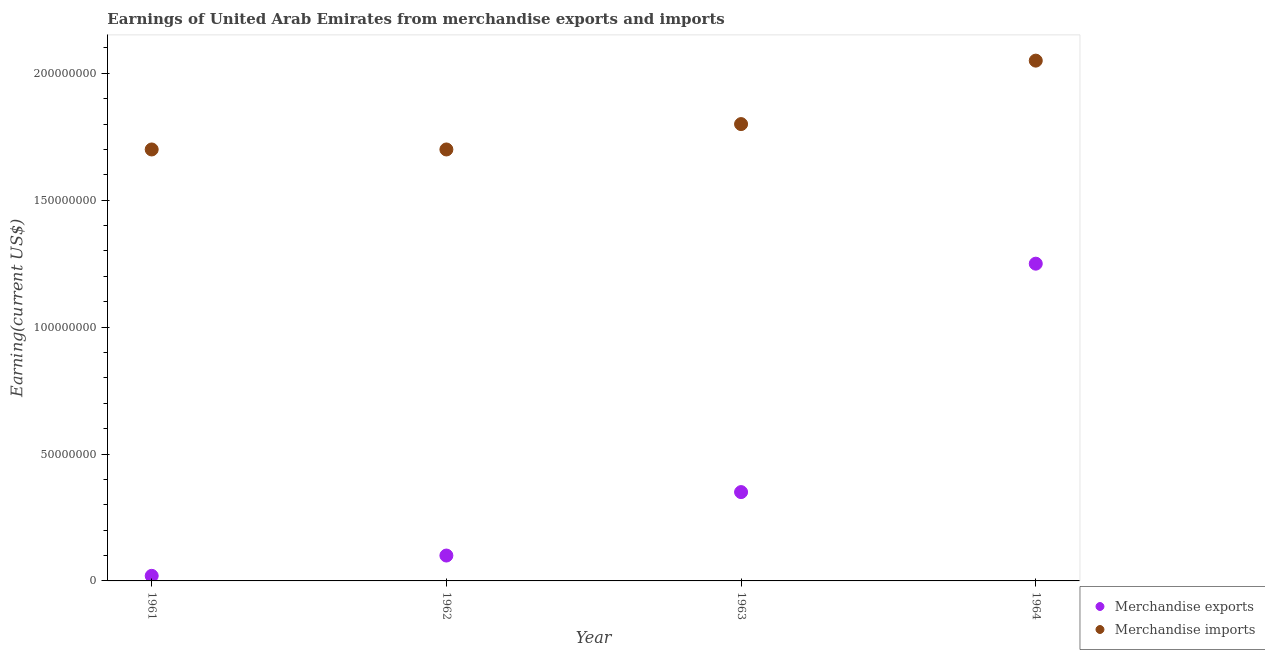How many different coloured dotlines are there?
Your answer should be compact. 2. What is the earnings from merchandise exports in 1964?
Ensure brevity in your answer.  1.25e+08. Across all years, what is the maximum earnings from merchandise imports?
Offer a very short reply. 2.05e+08. Across all years, what is the minimum earnings from merchandise exports?
Your answer should be compact. 2.00e+06. In which year was the earnings from merchandise imports maximum?
Keep it short and to the point. 1964. What is the total earnings from merchandise exports in the graph?
Give a very brief answer. 1.72e+08. What is the difference between the earnings from merchandise imports in 1961 and that in 1964?
Provide a short and direct response. -3.50e+07. What is the difference between the earnings from merchandise imports in 1963 and the earnings from merchandise exports in 1961?
Your answer should be very brief. 1.78e+08. What is the average earnings from merchandise exports per year?
Offer a very short reply. 4.30e+07. In the year 1961, what is the difference between the earnings from merchandise imports and earnings from merchandise exports?
Your response must be concise. 1.68e+08. In how many years, is the earnings from merchandise imports greater than 50000000 US$?
Your answer should be compact. 4. What is the ratio of the earnings from merchandise exports in 1963 to that in 1964?
Your answer should be compact. 0.28. Is the earnings from merchandise exports in 1961 less than that in 1963?
Ensure brevity in your answer.  Yes. Is the difference between the earnings from merchandise imports in 1961 and 1962 greater than the difference between the earnings from merchandise exports in 1961 and 1962?
Offer a very short reply. Yes. What is the difference between the highest and the second highest earnings from merchandise exports?
Provide a short and direct response. 9.00e+07. What is the difference between the highest and the lowest earnings from merchandise imports?
Make the answer very short. 3.50e+07. In how many years, is the earnings from merchandise imports greater than the average earnings from merchandise imports taken over all years?
Ensure brevity in your answer.  1. Is the sum of the earnings from merchandise exports in 1963 and 1964 greater than the maximum earnings from merchandise imports across all years?
Your answer should be compact. No. Does the earnings from merchandise imports monotonically increase over the years?
Your answer should be very brief. No. Is the earnings from merchandise exports strictly less than the earnings from merchandise imports over the years?
Provide a succinct answer. Yes. How many years are there in the graph?
Your answer should be compact. 4. Are the values on the major ticks of Y-axis written in scientific E-notation?
Offer a very short reply. No. Does the graph contain grids?
Make the answer very short. No. How many legend labels are there?
Your answer should be very brief. 2. How are the legend labels stacked?
Provide a succinct answer. Vertical. What is the title of the graph?
Provide a succinct answer. Earnings of United Arab Emirates from merchandise exports and imports. Does "Drinking water services" appear as one of the legend labels in the graph?
Make the answer very short. No. What is the label or title of the X-axis?
Offer a terse response. Year. What is the label or title of the Y-axis?
Provide a short and direct response. Earning(current US$). What is the Earning(current US$) of Merchandise exports in 1961?
Provide a short and direct response. 2.00e+06. What is the Earning(current US$) in Merchandise imports in 1961?
Make the answer very short. 1.70e+08. What is the Earning(current US$) in Merchandise exports in 1962?
Ensure brevity in your answer.  1.00e+07. What is the Earning(current US$) of Merchandise imports in 1962?
Give a very brief answer. 1.70e+08. What is the Earning(current US$) of Merchandise exports in 1963?
Your answer should be very brief. 3.50e+07. What is the Earning(current US$) in Merchandise imports in 1963?
Ensure brevity in your answer.  1.80e+08. What is the Earning(current US$) in Merchandise exports in 1964?
Your response must be concise. 1.25e+08. What is the Earning(current US$) of Merchandise imports in 1964?
Your answer should be compact. 2.05e+08. Across all years, what is the maximum Earning(current US$) in Merchandise exports?
Make the answer very short. 1.25e+08. Across all years, what is the maximum Earning(current US$) of Merchandise imports?
Provide a succinct answer. 2.05e+08. Across all years, what is the minimum Earning(current US$) in Merchandise imports?
Give a very brief answer. 1.70e+08. What is the total Earning(current US$) in Merchandise exports in the graph?
Your answer should be very brief. 1.72e+08. What is the total Earning(current US$) of Merchandise imports in the graph?
Make the answer very short. 7.25e+08. What is the difference between the Earning(current US$) of Merchandise exports in 1961 and that in 1962?
Your response must be concise. -8.00e+06. What is the difference between the Earning(current US$) of Merchandise imports in 1961 and that in 1962?
Give a very brief answer. 0. What is the difference between the Earning(current US$) in Merchandise exports in 1961 and that in 1963?
Your answer should be compact. -3.30e+07. What is the difference between the Earning(current US$) of Merchandise imports in 1961 and that in 1963?
Make the answer very short. -1.00e+07. What is the difference between the Earning(current US$) of Merchandise exports in 1961 and that in 1964?
Your response must be concise. -1.23e+08. What is the difference between the Earning(current US$) of Merchandise imports in 1961 and that in 1964?
Provide a short and direct response. -3.50e+07. What is the difference between the Earning(current US$) of Merchandise exports in 1962 and that in 1963?
Your answer should be very brief. -2.50e+07. What is the difference between the Earning(current US$) in Merchandise imports in 1962 and that in 1963?
Ensure brevity in your answer.  -1.00e+07. What is the difference between the Earning(current US$) in Merchandise exports in 1962 and that in 1964?
Provide a short and direct response. -1.15e+08. What is the difference between the Earning(current US$) in Merchandise imports in 1962 and that in 1964?
Provide a short and direct response. -3.50e+07. What is the difference between the Earning(current US$) in Merchandise exports in 1963 and that in 1964?
Make the answer very short. -9.00e+07. What is the difference between the Earning(current US$) in Merchandise imports in 1963 and that in 1964?
Your response must be concise. -2.50e+07. What is the difference between the Earning(current US$) of Merchandise exports in 1961 and the Earning(current US$) of Merchandise imports in 1962?
Your response must be concise. -1.68e+08. What is the difference between the Earning(current US$) in Merchandise exports in 1961 and the Earning(current US$) in Merchandise imports in 1963?
Your response must be concise. -1.78e+08. What is the difference between the Earning(current US$) in Merchandise exports in 1961 and the Earning(current US$) in Merchandise imports in 1964?
Offer a very short reply. -2.03e+08. What is the difference between the Earning(current US$) in Merchandise exports in 1962 and the Earning(current US$) in Merchandise imports in 1963?
Make the answer very short. -1.70e+08. What is the difference between the Earning(current US$) of Merchandise exports in 1962 and the Earning(current US$) of Merchandise imports in 1964?
Make the answer very short. -1.95e+08. What is the difference between the Earning(current US$) of Merchandise exports in 1963 and the Earning(current US$) of Merchandise imports in 1964?
Ensure brevity in your answer.  -1.70e+08. What is the average Earning(current US$) in Merchandise exports per year?
Ensure brevity in your answer.  4.30e+07. What is the average Earning(current US$) in Merchandise imports per year?
Provide a succinct answer. 1.81e+08. In the year 1961, what is the difference between the Earning(current US$) of Merchandise exports and Earning(current US$) of Merchandise imports?
Your response must be concise. -1.68e+08. In the year 1962, what is the difference between the Earning(current US$) of Merchandise exports and Earning(current US$) of Merchandise imports?
Provide a succinct answer. -1.60e+08. In the year 1963, what is the difference between the Earning(current US$) in Merchandise exports and Earning(current US$) in Merchandise imports?
Offer a very short reply. -1.45e+08. In the year 1964, what is the difference between the Earning(current US$) in Merchandise exports and Earning(current US$) in Merchandise imports?
Ensure brevity in your answer.  -8.00e+07. What is the ratio of the Earning(current US$) in Merchandise imports in 1961 to that in 1962?
Your answer should be compact. 1. What is the ratio of the Earning(current US$) in Merchandise exports in 1961 to that in 1963?
Ensure brevity in your answer.  0.06. What is the ratio of the Earning(current US$) of Merchandise exports in 1961 to that in 1964?
Give a very brief answer. 0.02. What is the ratio of the Earning(current US$) in Merchandise imports in 1961 to that in 1964?
Keep it short and to the point. 0.83. What is the ratio of the Earning(current US$) in Merchandise exports in 1962 to that in 1963?
Make the answer very short. 0.29. What is the ratio of the Earning(current US$) in Merchandise exports in 1962 to that in 1964?
Your response must be concise. 0.08. What is the ratio of the Earning(current US$) of Merchandise imports in 1962 to that in 1964?
Make the answer very short. 0.83. What is the ratio of the Earning(current US$) of Merchandise exports in 1963 to that in 1964?
Provide a succinct answer. 0.28. What is the ratio of the Earning(current US$) of Merchandise imports in 1963 to that in 1964?
Offer a terse response. 0.88. What is the difference between the highest and the second highest Earning(current US$) in Merchandise exports?
Make the answer very short. 9.00e+07. What is the difference between the highest and the second highest Earning(current US$) of Merchandise imports?
Give a very brief answer. 2.50e+07. What is the difference between the highest and the lowest Earning(current US$) in Merchandise exports?
Offer a terse response. 1.23e+08. What is the difference between the highest and the lowest Earning(current US$) of Merchandise imports?
Provide a succinct answer. 3.50e+07. 